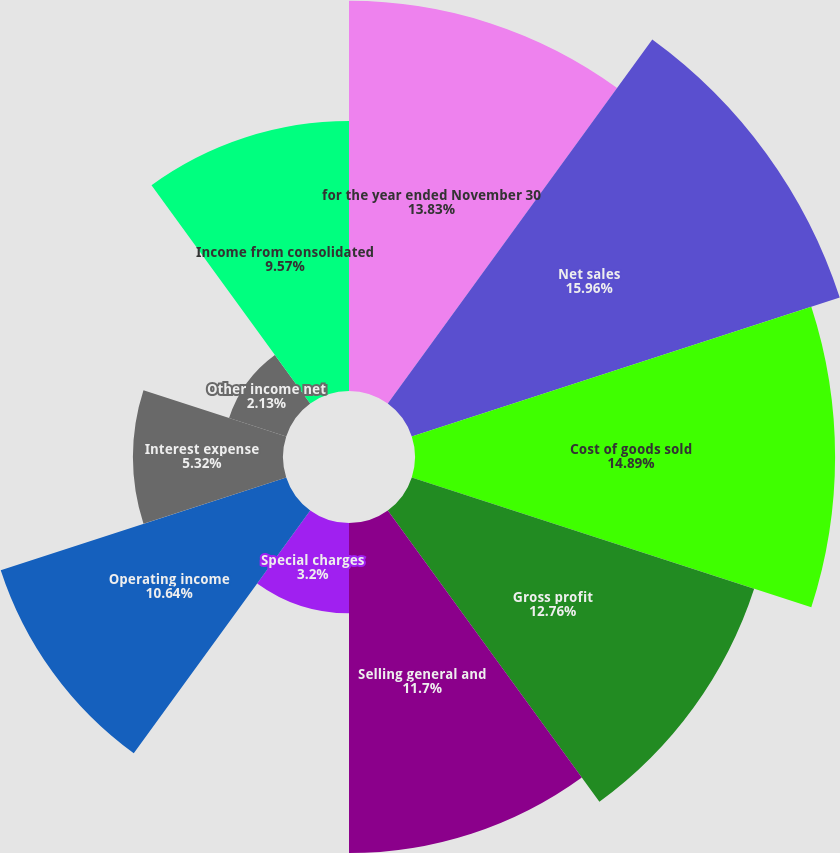Convert chart. <chart><loc_0><loc_0><loc_500><loc_500><pie_chart><fcel>for the year ended November 30<fcel>Net sales<fcel>Cost of goods sold<fcel>Gross profit<fcel>Selling general and<fcel>Special charges<fcel>Operating income<fcel>Interest expense<fcel>Other income net<fcel>Income from consolidated<nl><fcel>13.83%<fcel>15.95%<fcel>14.89%<fcel>12.76%<fcel>11.7%<fcel>3.2%<fcel>10.64%<fcel>5.32%<fcel>2.13%<fcel>9.57%<nl></chart> 